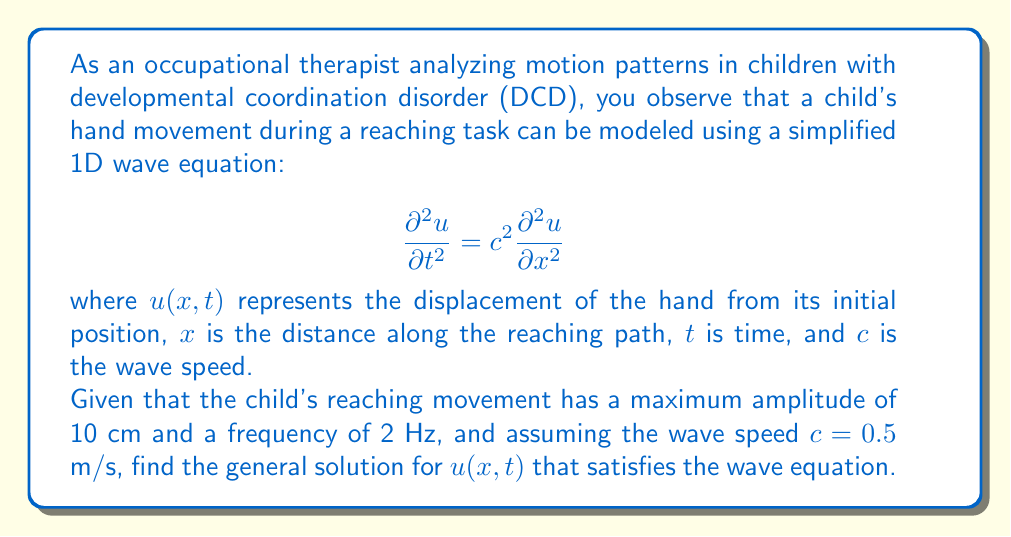Give your solution to this math problem. To solve this problem, we'll follow these steps:

1) The general solution for a 1D wave equation is given by:

   $$u(x,t) = f(x-ct) + g(x+ct)$$

   where $f$ and $g$ are arbitrary functions.

2) Given the oscillatory nature of the reaching movement, we can assume a sinusoidal solution:

   $$u(x,t) = A \sin(kx - \omega t) + B \sin(kx + \omega t)$$

   where $A$ and $B$ are amplitudes, $k$ is the wave number, and $\omega$ is the angular frequency.

3) We're given that the maximum amplitude is 10 cm, so $A + B = 0.1$ m.

4) The frequency is 2 Hz, so $\omega = 2\pi f = 4\pi$ rad/s.

5) We can find $k$ using the relation $c = \omega/k$:

   $$k = \frac{\omega}{c} = \frac{4\pi}{0.5} = 8\pi \text{ m}^{-1}$$

6) Substituting these values into our solution:

   $$u(x,t) = A \sin(8\pi x - 4\pi t) + B \sin(8\pi x + 4\pi t)$$

7) To satisfy the maximum amplitude condition:

   $$A + B = 0.1$$

8) We can choose $A = B = 0.05$ to satisfy this condition and create a symmetric solution.

Therefore, the general solution is:

$$u(x,t) = 0.05 \sin(8\pi x - 4\pi t) + 0.05 \sin(8\pi x + 4\pi t)$$
Answer: $$u(x,t) = 0.05 \sin(8\pi x - 4\pi t) + 0.05 \sin(8\pi x + 4\pi t)$$ 